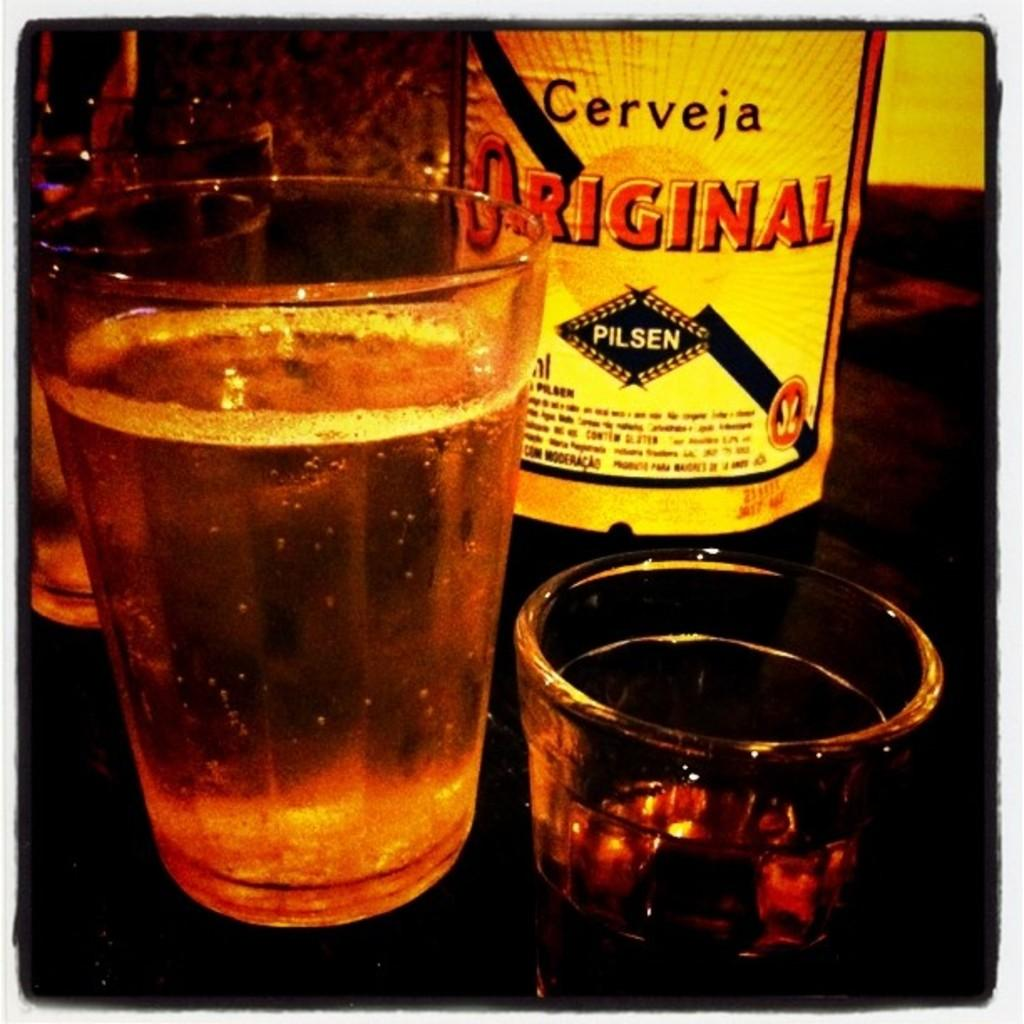Provide a one-sentence caption for the provided image. A bottle of Cerveja Original sitting next to two glasses. 